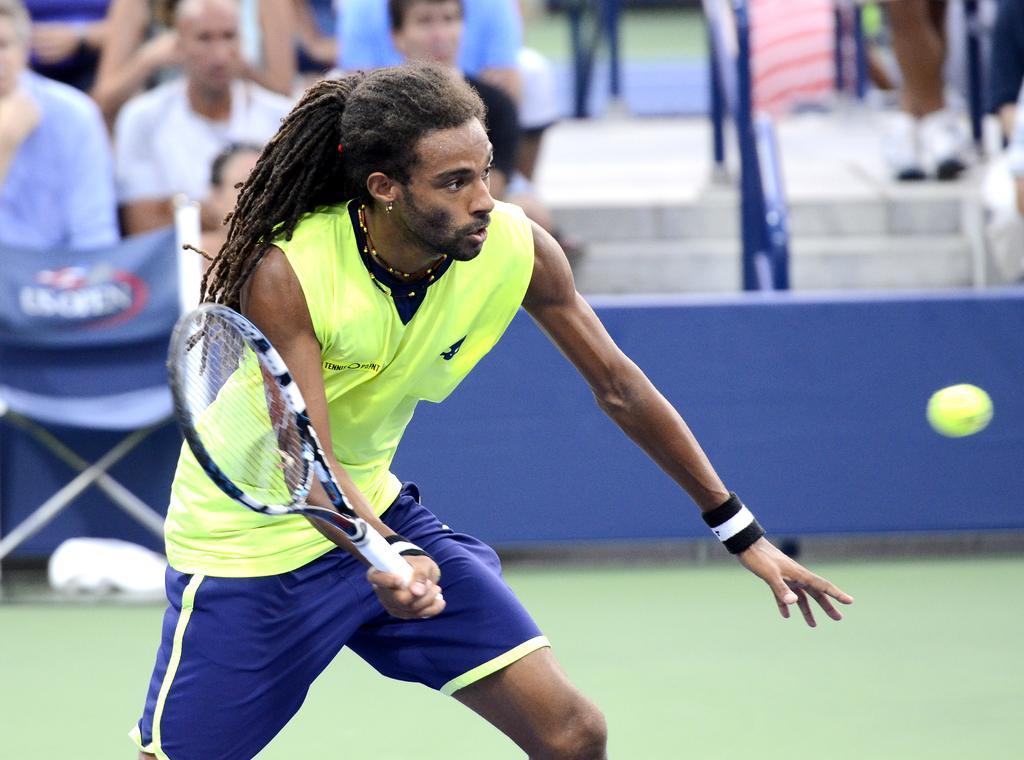Please provide a concise description of this image. In this picture we can see a man playing a tennis game, he is holding a tennis bat, we can see a ball here, in the background there are some people sitting and looking at the game, there is a chair here. 